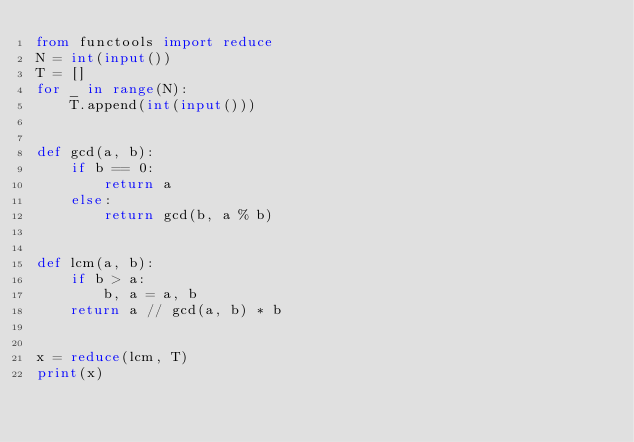Convert code to text. <code><loc_0><loc_0><loc_500><loc_500><_Python_>from functools import reduce
N = int(input())
T = []
for _ in range(N):
    T.append(int(input()))


def gcd(a, b):
    if b == 0:
        return a
    else:
        return gcd(b, a % b)


def lcm(a, b):
    if b > a:
        b, a = a, b
    return a // gcd(a, b) * b


x = reduce(lcm, T)
print(x)
</code> 